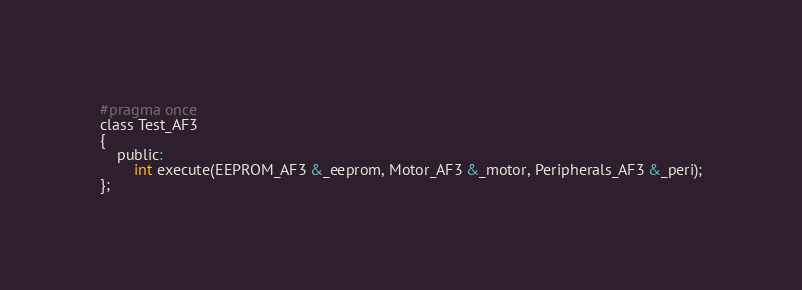<code> <loc_0><loc_0><loc_500><loc_500><_C_>
#pragma once
class Test_AF3
{
    public:
        int execute(EEPROM_AF3 &_eeprom, Motor_AF3 &_motor, Peripherals_AF3 &_peri);
};</code> 